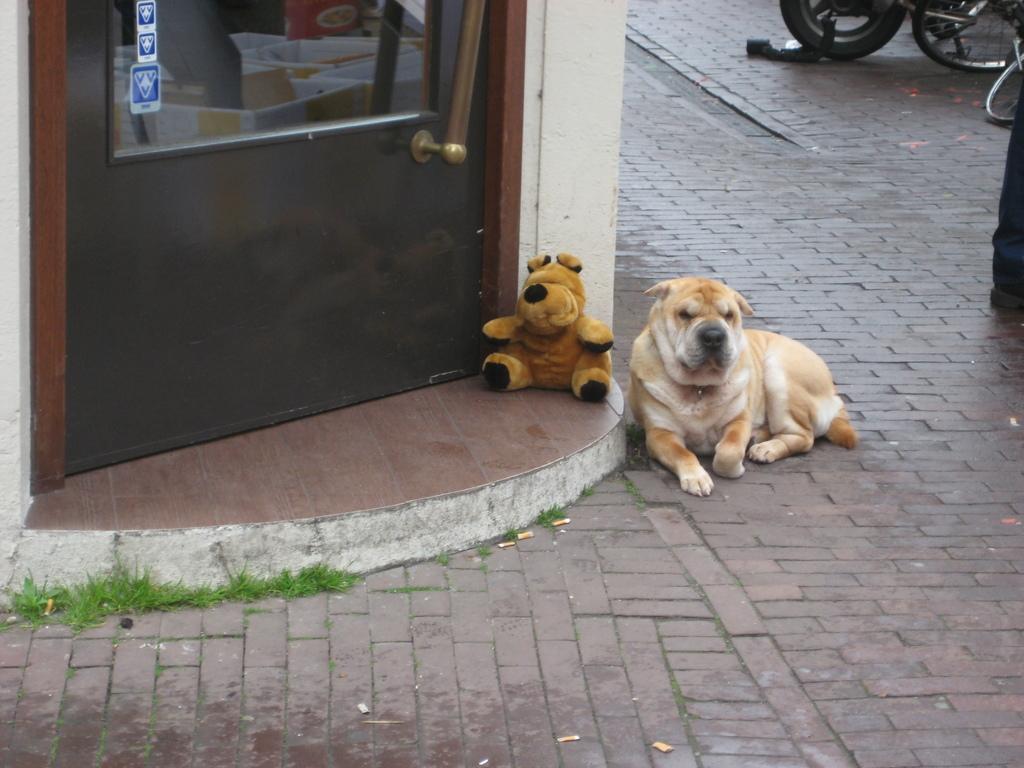In one or two sentences, can you explain what this image depicts? In this image I can see the dog in brown and white color and the dog is on the road. In front I can see the door and the toy. In the background I can see few vehicles. 